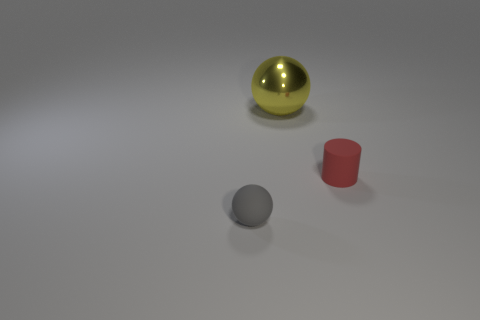Add 3 tiny blue balls. How many objects exist? 6 Subtract all yellow balls. How many balls are left? 1 Subtract all balls. How many objects are left? 1 Subtract all blue blocks. How many green cylinders are left? 0 Subtract all balls. Subtract all large purple metallic objects. How many objects are left? 1 Add 2 large spheres. How many large spheres are left? 3 Add 2 gray metal things. How many gray metal things exist? 2 Subtract 0 purple cylinders. How many objects are left? 3 Subtract all blue balls. Subtract all red blocks. How many balls are left? 2 